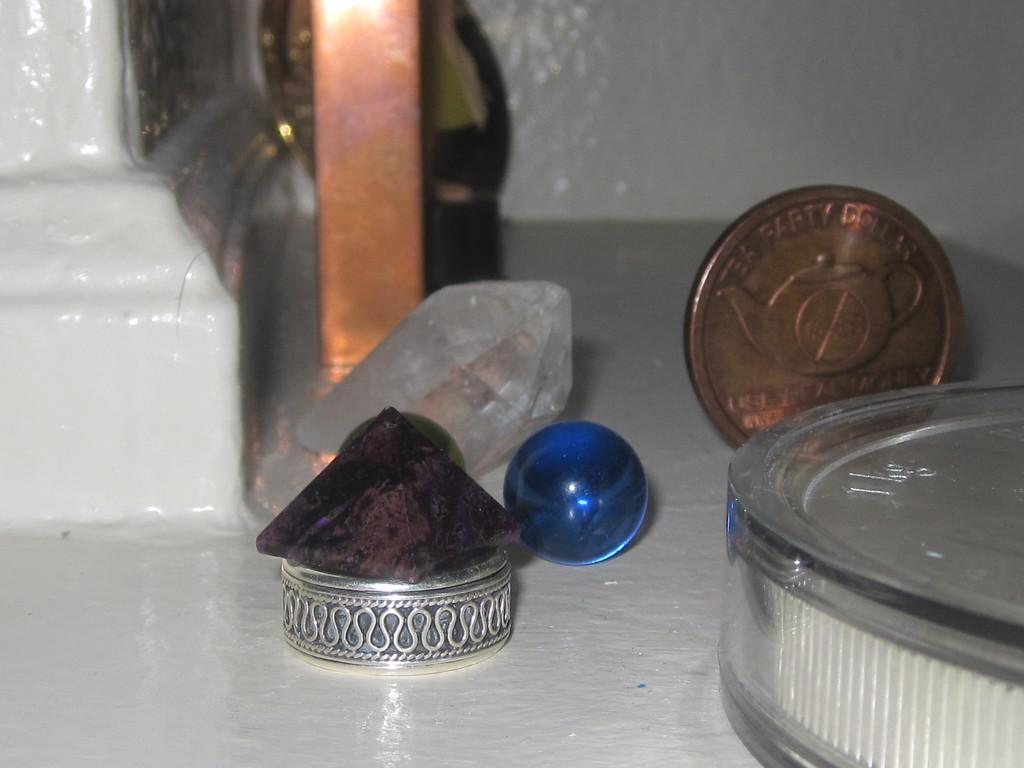Provide a one-sentence caption for the provided image. A bronze coin saying Tea Party sits on a table wiht a marble and some precious stones. 